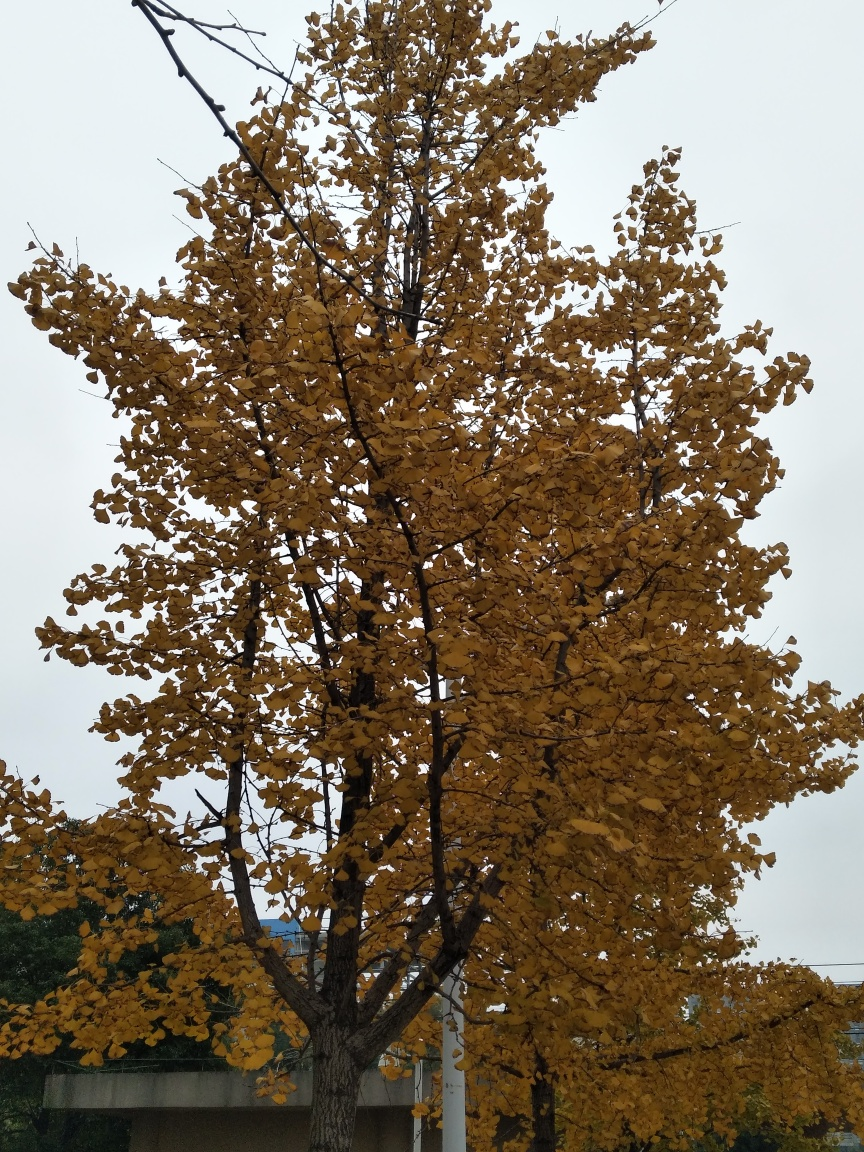How would you describe the season and mood depicted in this image? The image encapsulates the essence of autumn, characterized by the golden-yellow leaves that dominate the tree. This season, often associated with transformation and maturity, is displayed in the foliage preparing to shed its leaves. The overcast sky hints at a tranquil, perhaps introspective mood, congruent with the fall season. 